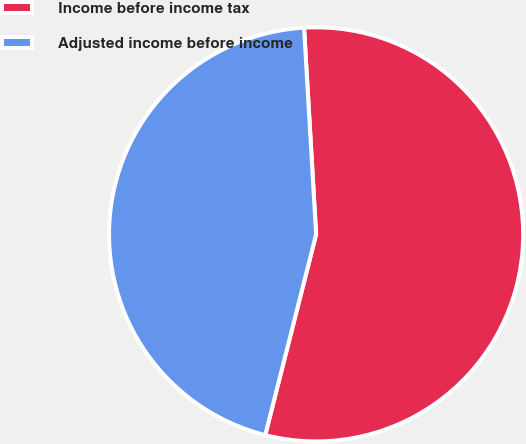Convert chart. <chart><loc_0><loc_0><loc_500><loc_500><pie_chart><fcel>Income before income tax<fcel>Adjusted income before income<nl><fcel>54.88%<fcel>45.12%<nl></chart> 